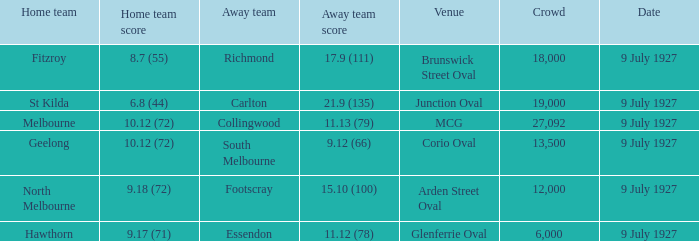Who was the away team playing the home team North Melbourne? Footscray. 